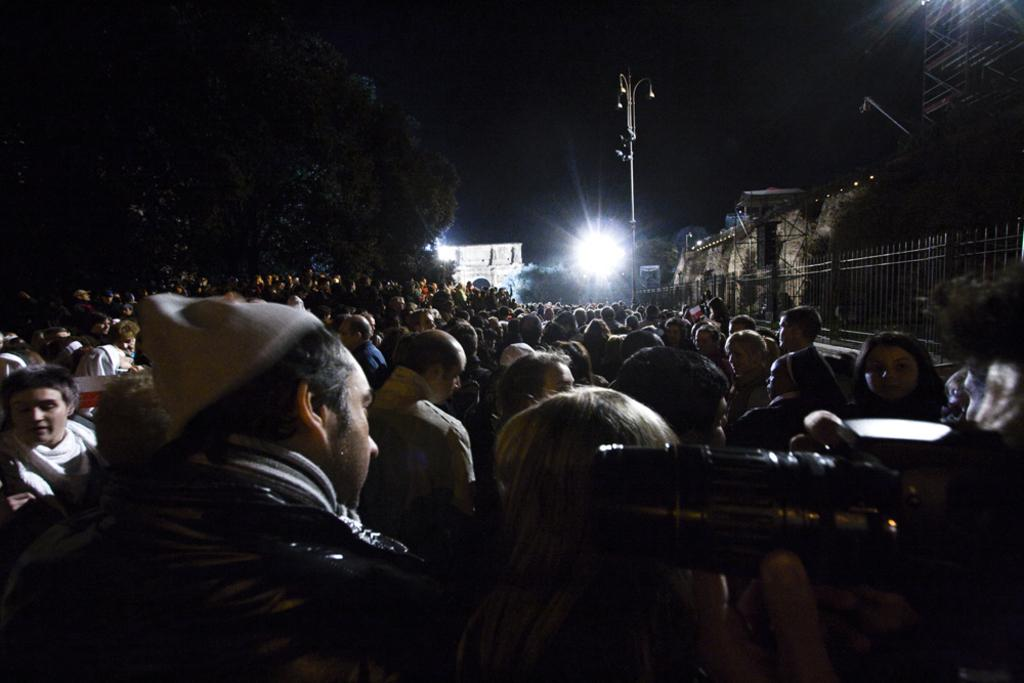What is the main subject of the image? The main subject of the image is a crowd. Can you describe the person on the right side of the image? There is a person holding a camera on the right side of the image. What can be seen in the background of the image? Trees, buildings, a fence, and a street pole are visible in the background of the image. What type of organization is responsible for the patch on the person's shirt in the image? There is no patch visible on the person's shirt in the image. What is the name of the person holding the camera in the image? The image does not provide the name of the person holding the camera. 